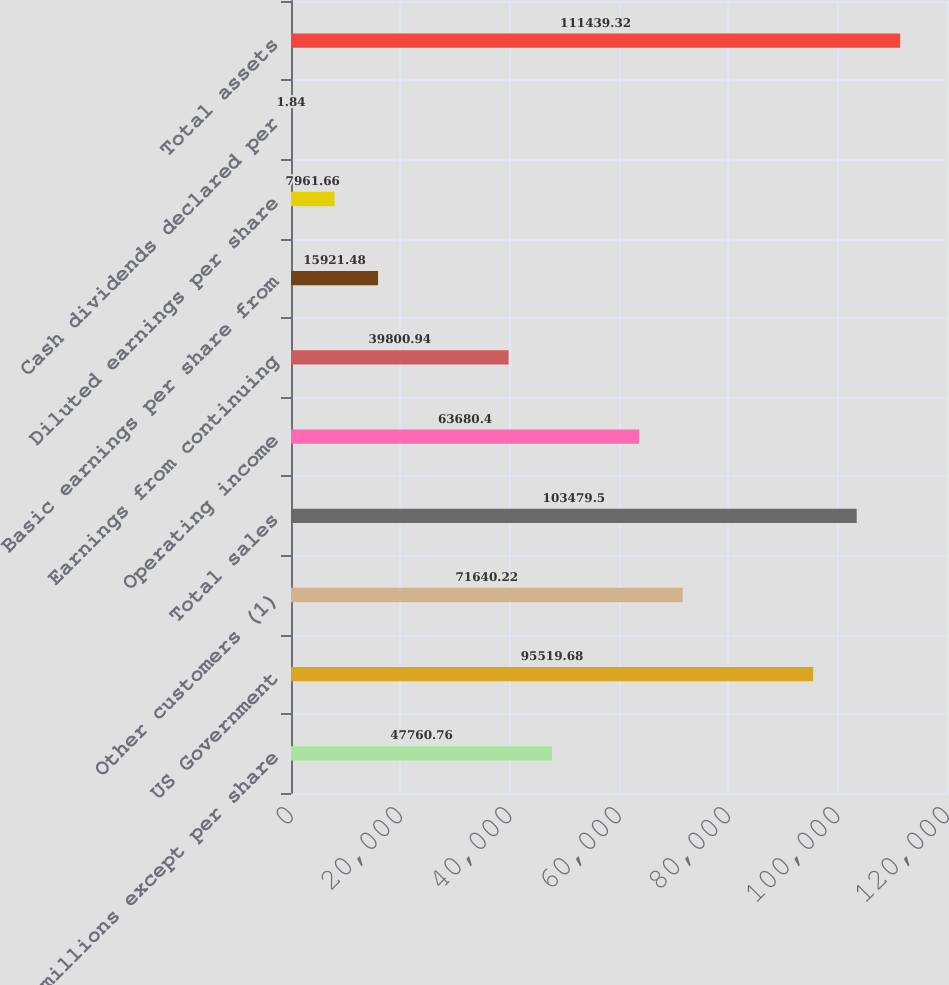Convert chart to OTSL. <chart><loc_0><loc_0><loc_500><loc_500><bar_chart><fcel>in millions except per share<fcel>US Government<fcel>Other customers (1)<fcel>Total sales<fcel>Operating income<fcel>Earnings from continuing<fcel>Basic earnings per share from<fcel>Diluted earnings per share<fcel>Cash dividends declared per<fcel>Total assets<nl><fcel>47760.8<fcel>95519.7<fcel>71640.2<fcel>103480<fcel>63680.4<fcel>39800.9<fcel>15921.5<fcel>7961.66<fcel>1.84<fcel>111439<nl></chart> 